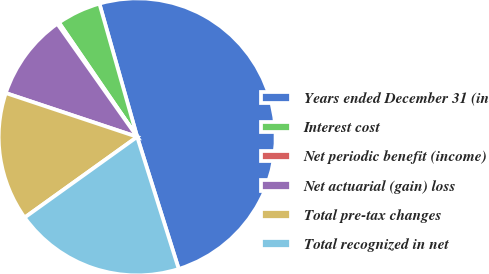Convert chart. <chart><loc_0><loc_0><loc_500><loc_500><pie_chart><fcel>Years ended December 31 (in<fcel>Interest cost<fcel>Net periodic benefit (income)<fcel>Net actuarial (gain) loss<fcel>Total pre-tax changes<fcel>Total recognized in net<nl><fcel>49.54%<fcel>5.16%<fcel>0.23%<fcel>10.09%<fcel>15.02%<fcel>19.95%<nl></chart> 